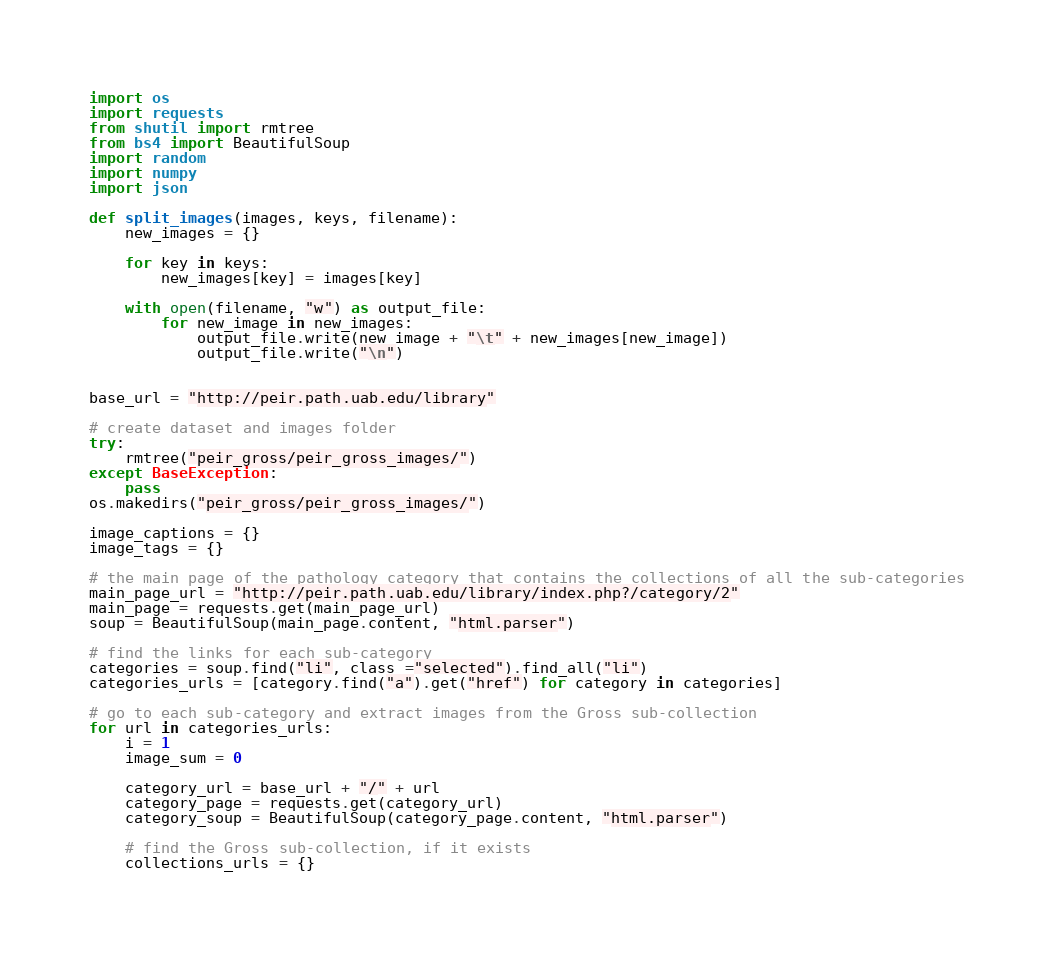<code> <loc_0><loc_0><loc_500><loc_500><_Python_>import os
import requests
from shutil import rmtree
from bs4 import BeautifulSoup
import random
import numpy
import json

def split_images(images, keys, filename):
	new_images = {}

	for key in keys:
		new_images[key] = images[key]

	with open(filename, "w") as output_file:
		for new_image in new_images:
			output_file.write(new_image + "\t" + new_images[new_image])
			output_file.write("\n")


base_url = "http://peir.path.uab.edu/library"

# create dataset and images folder
try:
	rmtree("peir_gross/peir_gross_images/")
except BaseException:
	pass
os.makedirs("peir_gross/peir_gross_images/")

image_captions = {}
image_tags = {}

# the main page of the pathology category that contains the collections of all the sub-categories
main_page_url = "http://peir.path.uab.edu/library/index.php?/category/2"
main_page = requests.get(main_page_url)
soup = BeautifulSoup(main_page.content, "html.parser")

# find the links for each sub-category
categories = soup.find("li", class_="selected").find_all("li")
categories_urls = [category.find("a").get("href") for category in categories]

# go to each sub-category and extract images from the Gross sub-collection
for url in categories_urls:
	i = 1
	image_sum = 0

	category_url = base_url + "/" + url
	category_page = requests.get(category_url)
	category_soup = BeautifulSoup(category_page.content, "html.parser")

	# find the Gross sub-collection, if it exists
	collections_urls = {}</code> 